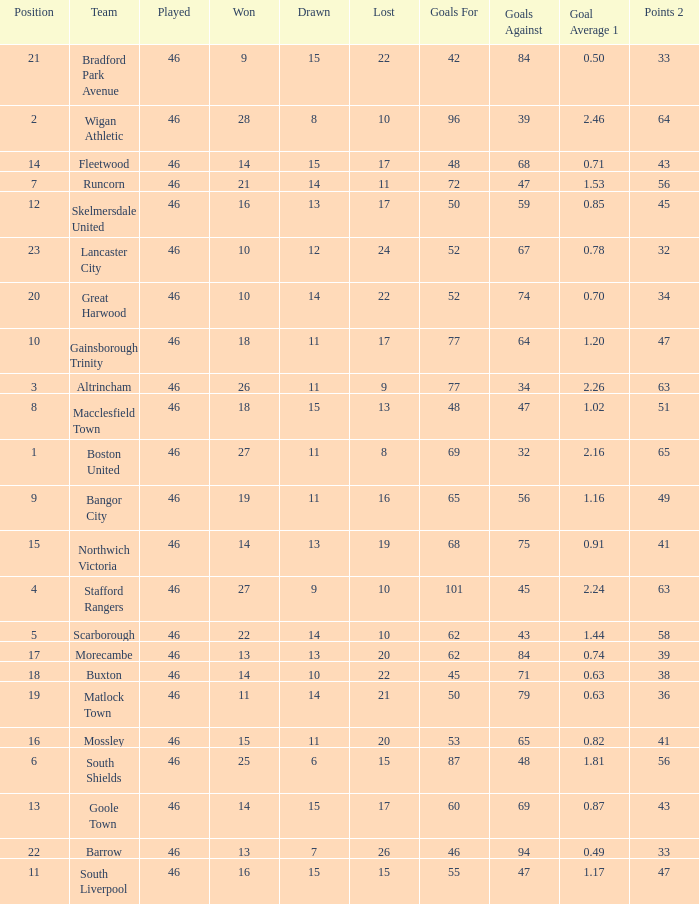How many points did Goole Town accumulate? 1.0. 